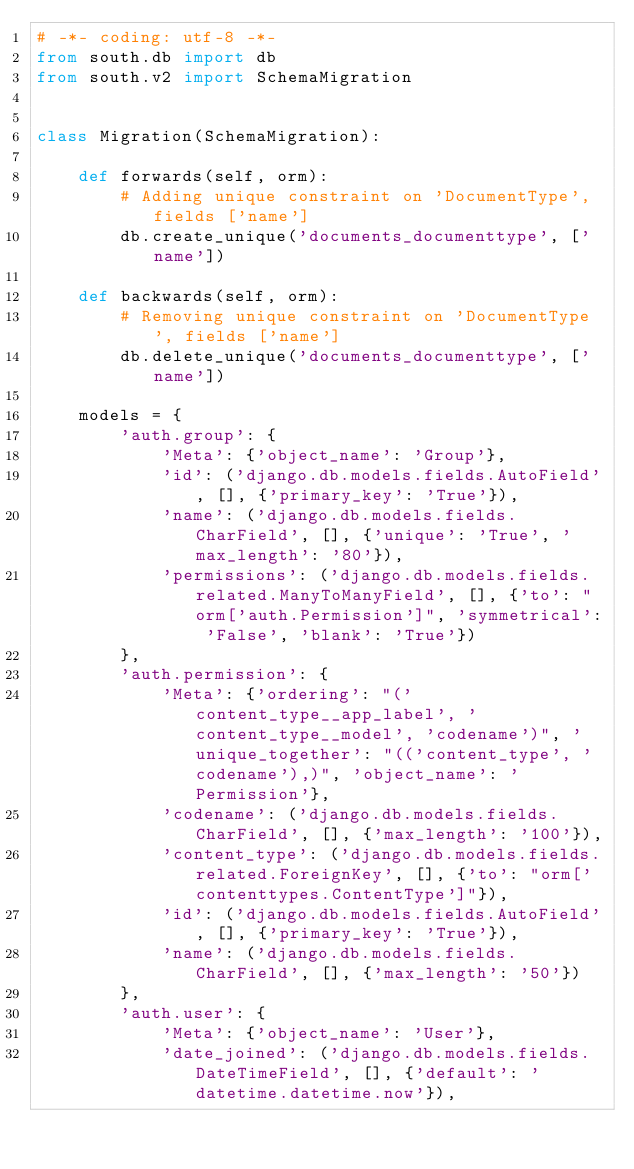<code> <loc_0><loc_0><loc_500><loc_500><_Python_># -*- coding: utf-8 -*-
from south.db import db
from south.v2 import SchemaMigration


class Migration(SchemaMigration):

    def forwards(self, orm):
        # Adding unique constraint on 'DocumentType', fields ['name']
        db.create_unique('documents_documenttype', ['name'])

    def backwards(self, orm):
        # Removing unique constraint on 'DocumentType', fields ['name']
        db.delete_unique('documents_documenttype', ['name'])

    models = {
        'auth.group': {
            'Meta': {'object_name': 'Group'},
            'id': ('django.db.models.fields.AutoField', [], {'primary_key': 'True'}),
            'name': ('django.db.models.fields.CharField', [], {'unique': 'True', 'max_length': '80'}),
            'permissions': ('django.db.models.fields.related.ManyToManyField', [], {'to': "orm['auth.Permission']", 'symmetrical': 'False', 'blank': 'True'})
        },
        'auth.permission': {
            'Meta': {'ordering': "('content_type__app_label', 'content_type__model', 'codename')", 'unique_together': "(('content_type', 'codename'),)", 'object_name': 'Permission'},
            'codename': ('django.db.models.fields.CharField', [], {'max_length': '100'}),
            'content_type': ('django.db.models.fields.related.ForeignKey', [], {'to': "orm['contenttypes.ContentType']"}),
            'id': ('django.db.models.fields.AutoField', [], {'primary_key': 'True'}),
            'name': ('django.db.models.fields.CharField', [], {'max_length': '50'})
        },
        'auth.user': {
            'Meta': {'object_name': 'User'},
            'date_joined': ('django.db.models.fields.DateTimeField', [], {'default': 'datetime.datetime.now'}),</code> 